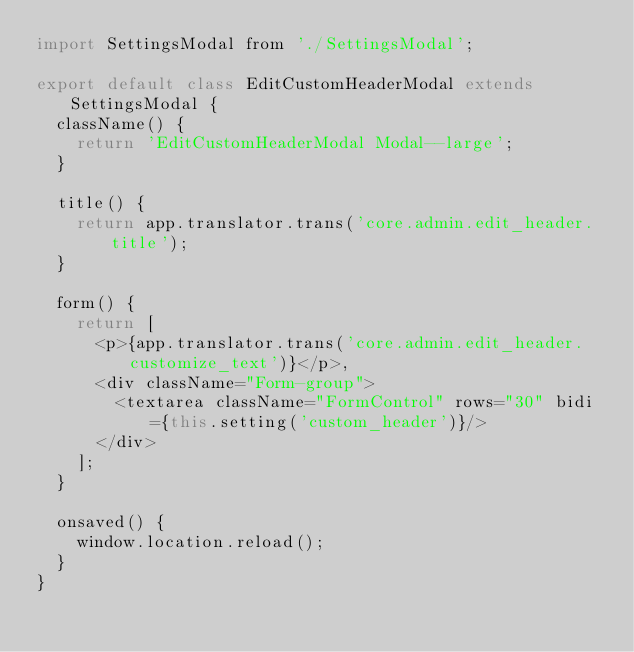Convert code to text. <code><loc_0><loc_0><loc_500><loc_500><_JavaScript_>import SettingsModal from './SettingsModal';

export default class EditCustomHeaderModal extends SettingsModal {
  className() {
    return 'EditCustomHeaderModal Modal--large';
  }

  title() {
    return app.translator.trans('core.admin.edit_header.title');
  }

  form() {
    return [
      <p>{app.translator.trans('core.admin.edit_header.customize_text')}</p>,
      <div className="Form-group">
        <textarea className="FormControl" rows="30" bidi={this.setting('custom_header')}/>
      </div>
    ];
  }

  onsaved() {
    window.location.reload();
  }
}
</code> 